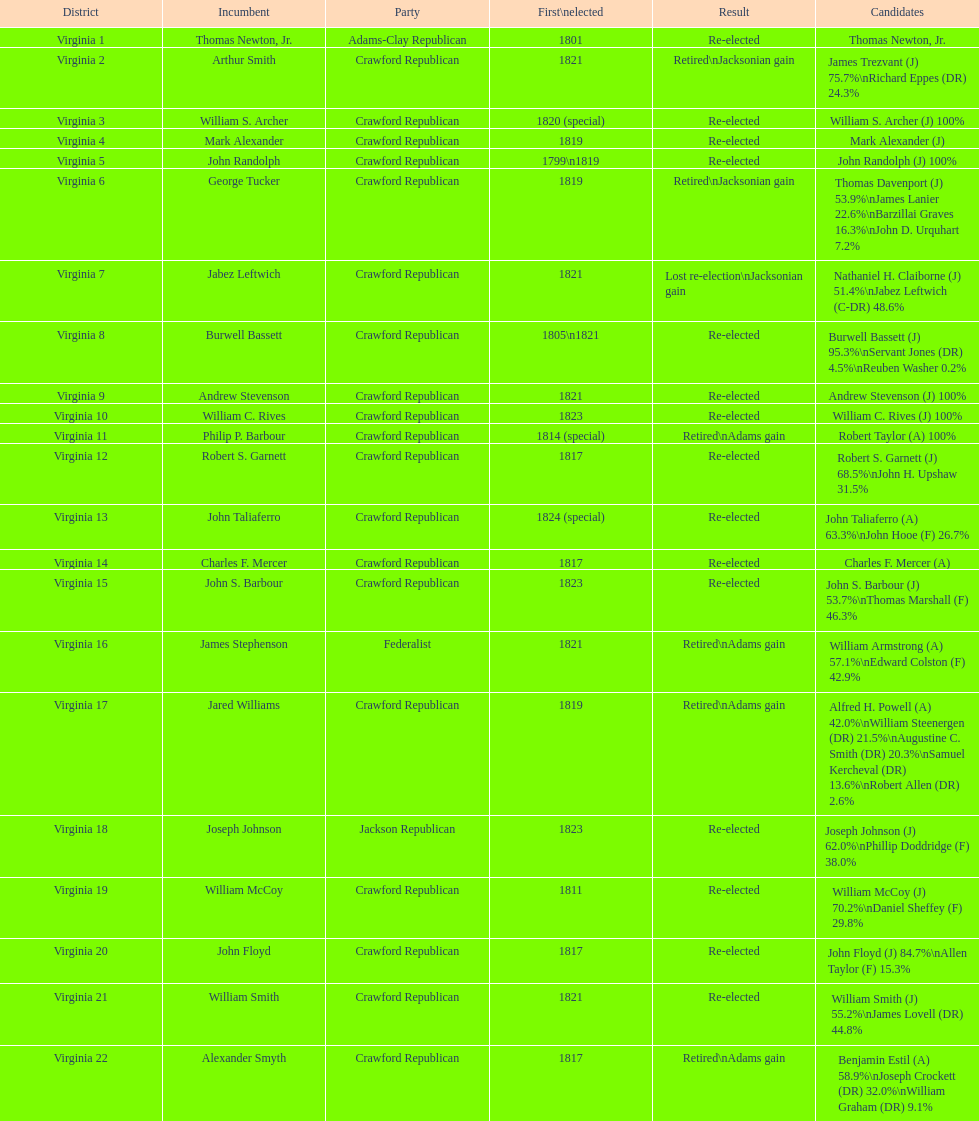What is the last party on this chart? Crawford Republican. 